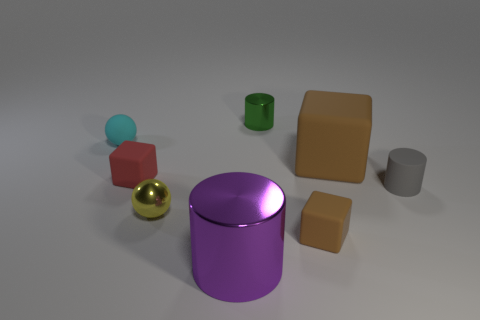What colors are the two cube-shaped objects? The two cube-shaped objects are colored red and cyan. Is the lighting in this image more concentrated on any particular object? The lighting does not favor a particular object strongly, but there appears to be a subtle highlight on the purple cylinder and the golden sphere, possibly making them stand out slightly. 